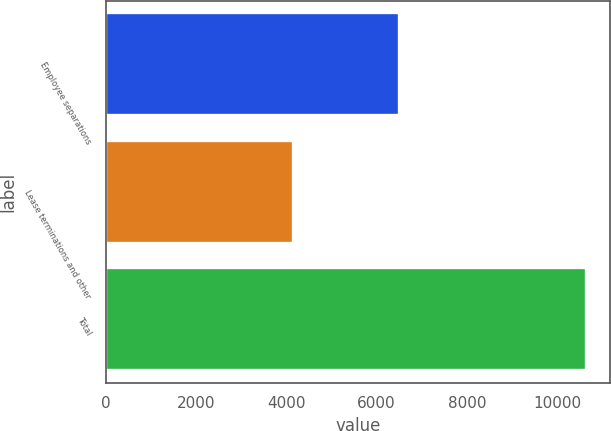Convert chart. <chart><loc_0><loc_0><loc_500><loc_500><bar_chart><fcel>Employee separations<fcel>Lease terminations and other<fcel>Total<nl><fcel>6501<fcel>4137<fcel>10638<nl></chart> 